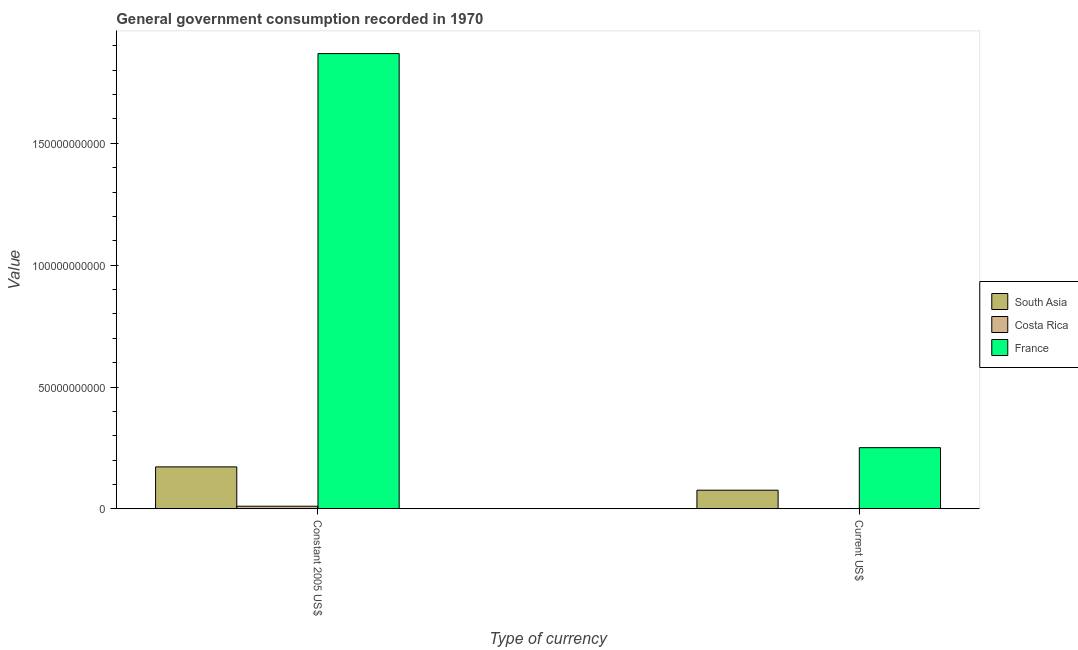How many different coloured bars are there?
Provide a short and direct response. 3. How many groups of bars are there?
Your answer should be compact. 2. Are the number of bars per tick equal to the number of legend labels?
Your answer should be compact. Yes. Are the number of bars on each tick of the X-axis equal?
Your answer should be very brief. Yes. How many bars are there on the 2nd tick from the left?
Provide a succinct answer. 3. What is the label of the 2nd group of bars from the left?
Your answer should be very brief. Current US$. What is the value consumed in current us$ in South Asia?
Offer a terse response. 7.66e+09. Across all countries, what is the maximum value consumed in current us$?
Ensure brevity in your answer.  2.51e+1. Across all countries, what is the minimum value consumed in constant 2005 us$?
Offer a very short reply. 1.08e+09. What is the total value consumed in current us$ in the graph?
Give a very brief answer. 3.29e+1. What is the difference between the value consumed in constant 2005 us$ in South Asia and that in France?
Ensure brevity in your answer.  -1.70e+11. What is the difference between the value consumed in current us$ in France and the value consumed in constant 2005 us$ in South Asia?
Your response must be concise. 7.89e+09. What is the average value consumed in constant 2005 us$ per country?
Your answer should be very brief. 6.84e+1. What is the difference between the value consumed in current us$ and value consumed in constant 2005 us$ in South Asia?
Ensure brevity in your answer.  -9.57e+09. What is the ratio of the value consumed in constant 2005 us$ in Costa Rica to that in France?
Offer a very short reply. 0.01. In how many countries, is the value consumed in constant 2005 us$ greater than the average value consumed in constant 2005 us$ taken over all countries?
Give a very brief answer. 1. What does the 3rd bar from the right in Current US$ represents?
Give a very brief answer. South Asia. How many bars are there?
Your response must be concise. 6. Are the values on the major ticks of Y-axis written in scientific E-notation?
Your response must be concise. No. Does the graph contain grids?
Your response must be concise. No. What is the title of the graph?
Ensure brevity in your answer.  General government consumption recorded in 1970. Does "Israel" appear as one of the legend labels in the graph?
Provide a short and direct response. No. What is the label or title of the X-axis?
Provide a succinct answer. Type of currency. What is the label or title of the Y-axis?
Your response must be concise. Value. What is the Value of South Asia in Constant 2005 US$?
Provide a succinct answer. 1.72e+1. What is the Value in Costa Rica in Constant 2005 US$?
Give a very brief answer. 1.08e+09. What is the Value in France in Constant 2005 US$?
Give a very brief answer. 1.87e+11. What is the Value in South Asia in Current US$?
Ensure brevity in your answer.  7.66e+09. What is the Value of Costa Rica in Current US$?
Ensure brevity in your answer.  1.24e+08. What is the Value of France in Current US$?
Your response must be concise. 2.51e+1. Across all Type of currency, what is the maximum Value in South Asia?
Make the answer very short. 1.72e+1. Across all Type of currency, what is the maximum Value of Costa Rica?
Give a very brief answer. 1.08e+09. Across all Type of currency, what is the maximum Value of France?
Give a very brief answer. 1.87e+11. Across all Type of currency, what is the minimum Value of South Asia?
Ensure brevity in your answer.  7.66e+09. Across all Type of currency, what is the minimum Value of Costa Rica?
Offer a terse response. 1.24e+08. Across all Type of currency, what is the minimum Value of France?
Your answer should be compact. 2.51e+1. What is the total Value of South Asia in the graph?
Provide a succinct answer. 2.49e+1. What is the total Value of Costa Rica in the graph?
Your answer should be very brief. 1.20e+09. What is the total Value of France in the graph?
Make the answer very short. 2.12e+11. What is the difference between the Value in South Asia in Constant 2005 US$ and that in Current US$?
Offer a terse response. 9.57e+09. What is the difference between the Value of Costa Rica in Constant 2005 US$ and that in Current US$?
Offer a terse response. 9.52e+08. What is the difference between the Value in France in Constant 2005 US$ and that in Current US$?
Your answer should be compact. 1.62e+11. What is the difference between the Value in South Asia in Constant 2005 US$ and the Value in Costa Rica in Current US$?
Your answer should be compact. 1.71e+1. What is the difference between the Value of South Asia in Constant 2005 US$ and the Value of France in Current US$?
Provide a succinct answer. -7.89e+09. What is the difference between the Value of Costa Rica in Constant 2005 US$ and the Value of France in Current US$?
Offer a very short reply. -2.40e+1. What is the average Value in South Asia per Type of currency?
Provide a short and direct response. 1.24e+1. What is the average Value of Costa Rica per Type of currency?
Provide a short and direct response. 6.00e+08. What is the average Value of France per Type of currency?
Your response must be concise. 1.06e+11. What is the difference between the Value in South Asia and Value in Costa Rica in Constant 2005 US$?
Offer a terse response. 1.61e+1. What is the difference between the Value of South Asia and Value of France in Constant 2005 US$?
Give a very brief answer. -1.70e+11. What is the difference between the Value of Costa Rica and Value of France in Constant 2005 US$?
Provide a short and direct response. -1.86e+11. What is the difference between the Value of South Asia and Value of Costa Rica in Current US$?
Your response must be concise. 7.53e+09. What is the difference between the Value in South Asia and Value in France in Current US$?
Keep it short and to the point. -1.75e+1. What is the difference between the Value of Costa Rica and Value of France in Current US$?
Offer a very short reply. -2.50e+1. What is the ratio of the Value of South Asia in Constant 2005 US$ to that in Current US$?
Ensure brevity in your answer.  2.25. What is the ratio of the Value of Costa Rica in Constant 2005 US$ to that in Current US$?
Make the answer very short. 8.69. What is the ratio of the Value of France in Constant 2005 US$ to that in Current US$?
Make the answer very short. 7.44. What is the difference between the highest and the second highest Value in South Asia?
Give a very brief answer. 9.57e+09. What is the difference between the highest and the second highest Value in Costa Rica?
Offer a terse response. 9.52e+08. What is the difference between the highest and the second highest Value of France?
Your answer should be compact. 1.62e+11. What is the difference between the highest and the lowest Value in South Asia?
Offer a very short reply. 9.57e+09. What is the difference between the highest and the lowest Value in Costa Rica?
Provide a short and direct response. 9.52e+08. What is the difference between the highest and the lowest Value of France?
Offer a terse response. 1.62e+11. 